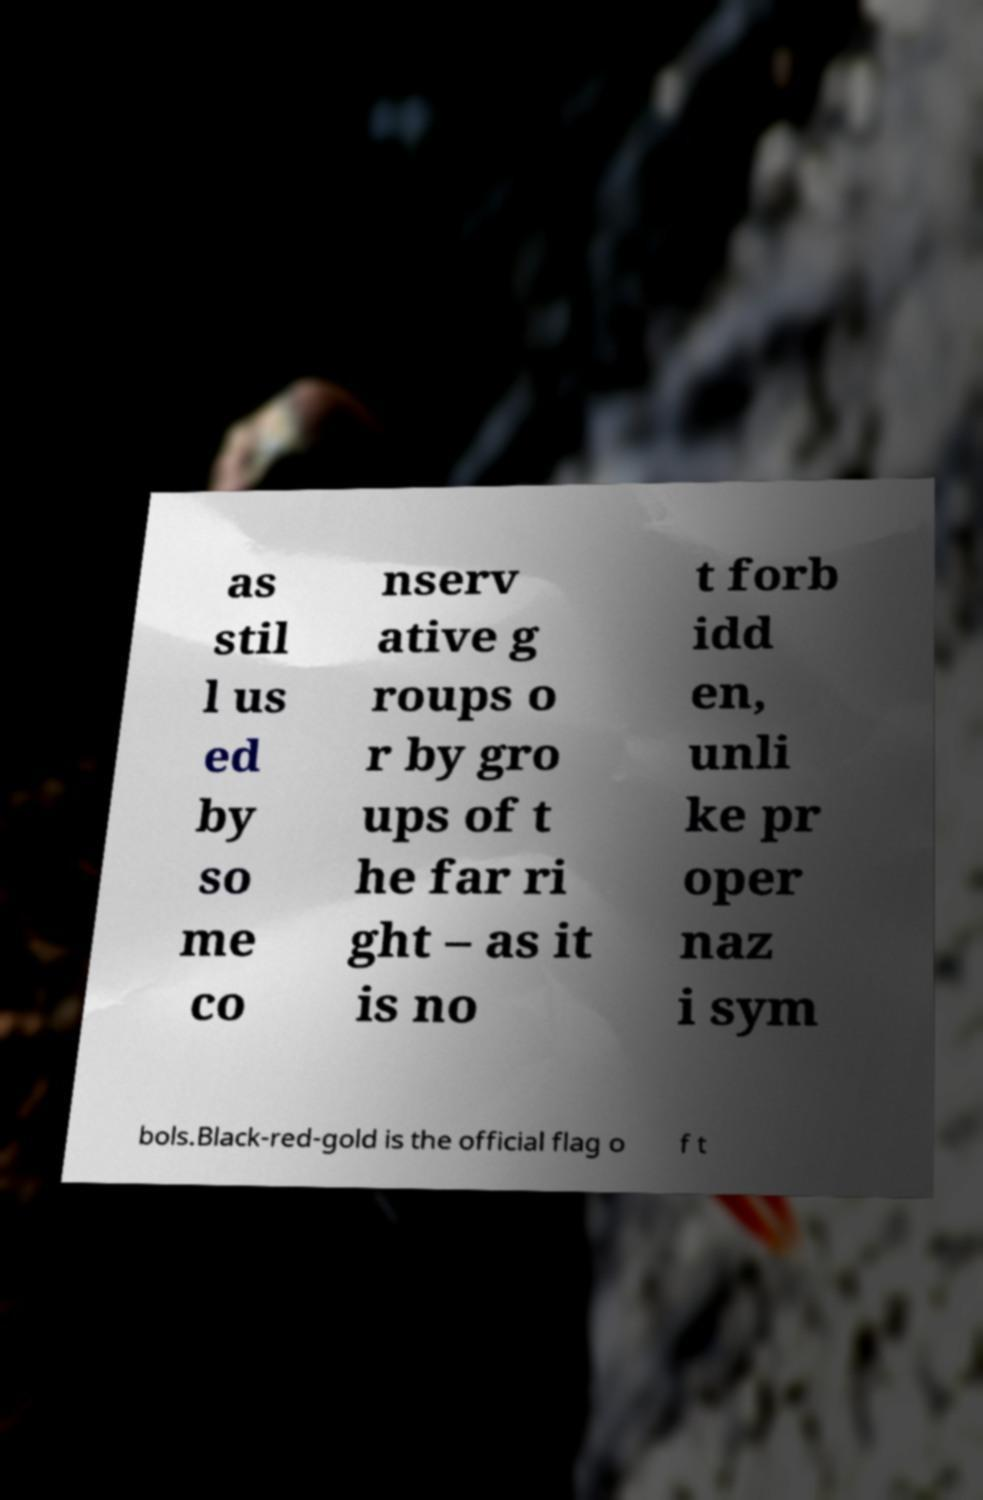Can you read and provide the text displayed in the image?This photo seems to have some interesting text. Can you extract and type it out for me? as stil l us ed by so me co nserv ative g roups o r by gro ups of t he far ri ght – as it is no t forb idd en, unli ke pr oper naz i sym bols.Black-red-gold is the official flag o f t 